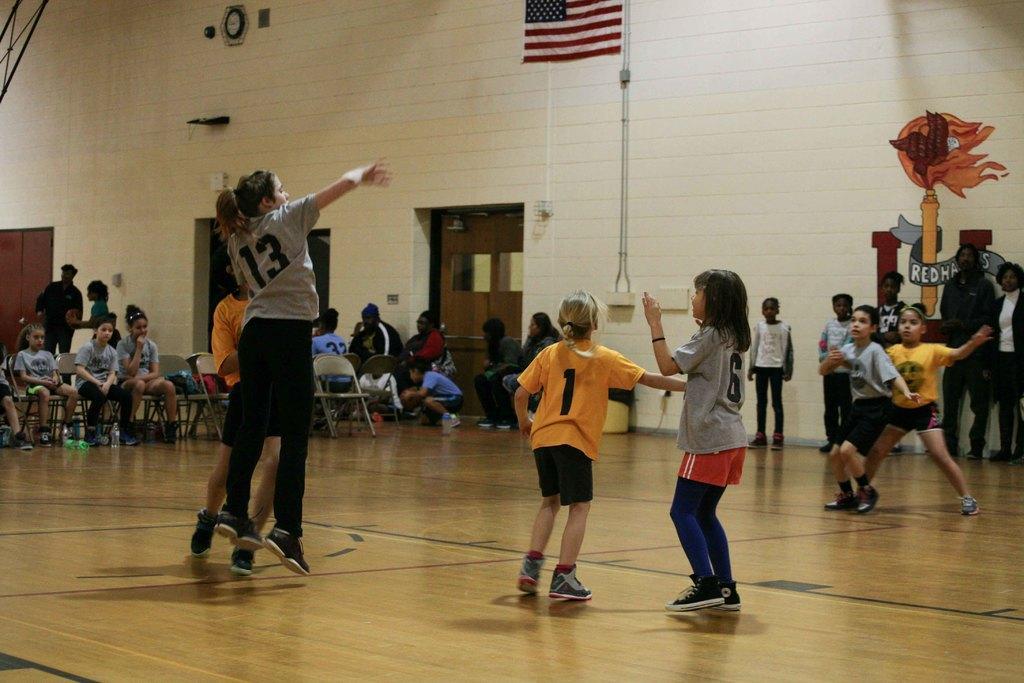Please provide a concise description of this image. In this picture I can see the court in front and I see number of people and in the background I see the wall and I see the doors and I see few of them are sitting on chairs. 